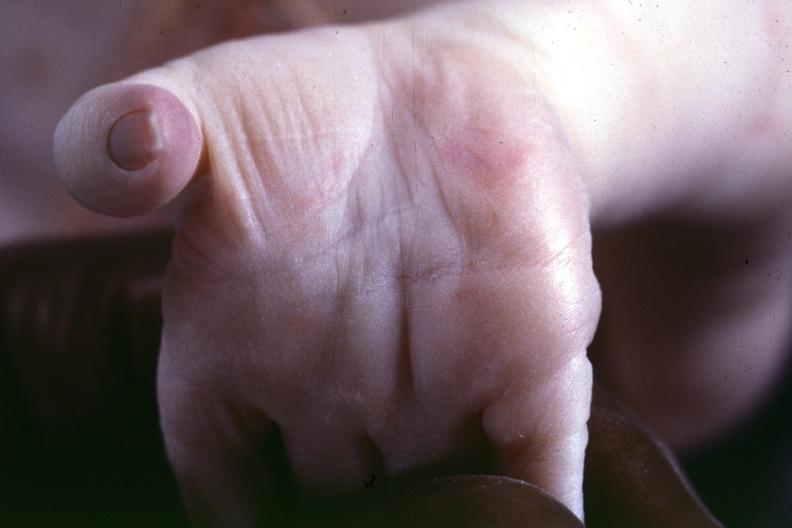what does this image show?
Answer the question using a single word or phrase. Source indicated 